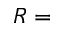<formula> <loc_0><loc_0><loc_500><loc_500>R =</formula> 